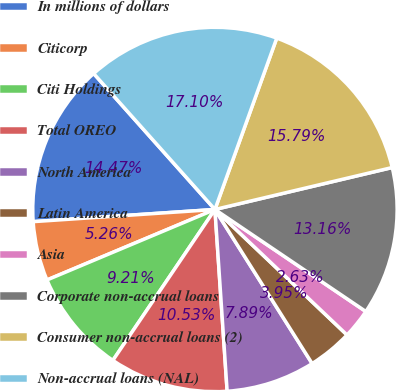<chart> <loc_0><loc_0><loc_500><loc_500><pie_chart><fcel>In millions of dollars<fcel>Citicorp<fcel>Citi Holdings<fcel>Total OREO<fcel>North America<fcel>Latin America<fcel>Asia<fcel>Corporate non-accrual loans<fcel>Consumer non-accrual loans (2)<fcel>Non-accrual loans (NAL)<nl><fcel>14.47%<fcel>5.26%<fcel>9.21%<fcel>10.53%<fcel>7.89%<fcel>3.95%<fcel>2.63%<fcel>13.16%<fcel>15.79%<fcel>17.1%<nl></chart> 